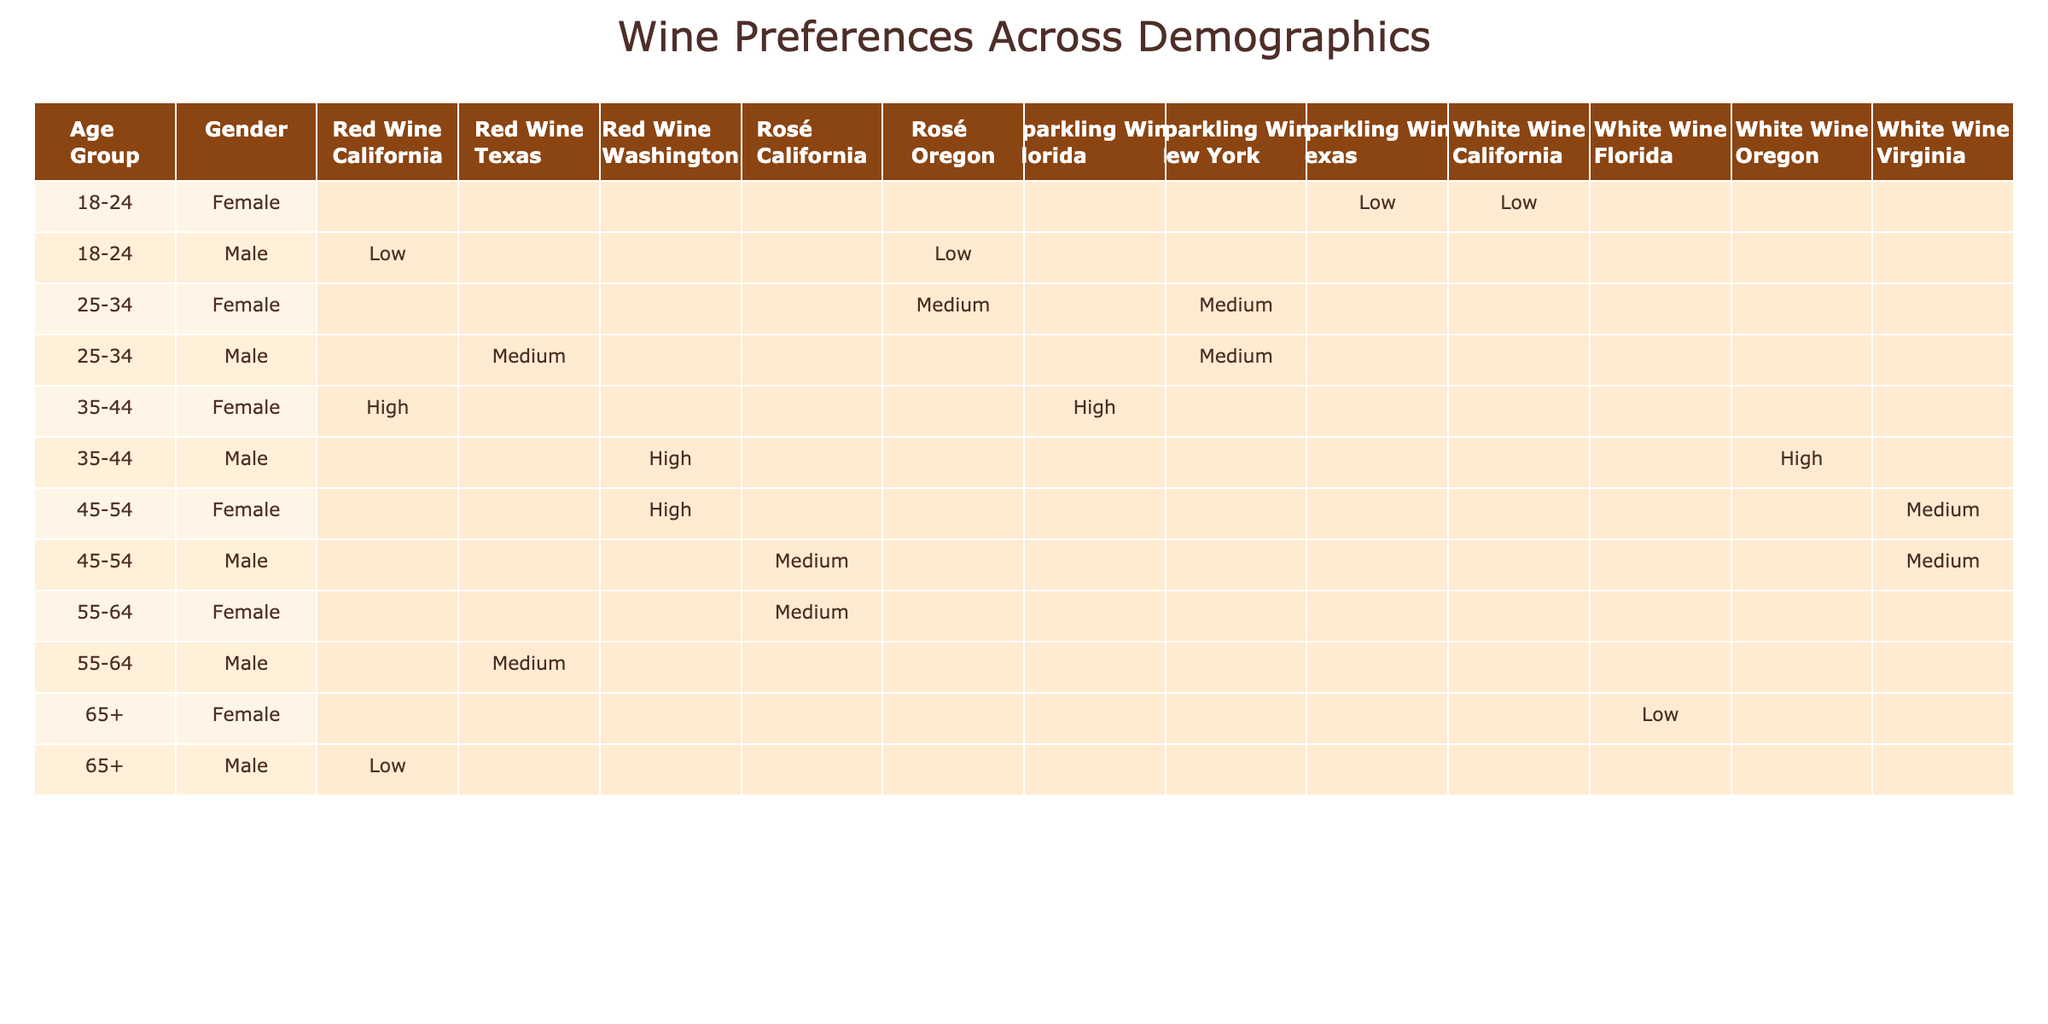What wine preference is most common among females in the 35-44 age group? In the 35-44 age group, the table indicates that females prefer "Red Wine" since it's the only wine type listed for this demographic in the table.
Answer: Red Wine What regions are associated with male consumers who prefer White Wine? The table shows males preferring White Wine in Oregon and Virginia. Therefore, the regions associated with this preference are Oregon and Virginia.
Answer: Oregon, Virginia Which age group has the highest variety of wine preferences listed in the table? By reviewing the table, the 25-34 age group shows four different wine preferences (Sparkling Wine, Red Wine, Rosé, and the specific regions). Hence, this age group has the highest variety of preferences.
Answer: 25-34 Are there any males in the 45-54 age group who prefer Rosé? Looking at the 45-54 age group in the table, there is one male who prefers Rosé, as indicated by the entry. Therefore, the statement is true.
Answer: Yes Among all demographics in California, which type of wine is preferred? By examining the California entries, White Wine is preferred by females aged 18-24 and males aged 35-44, while Red Wine is preferred by a male aged 65+. Therefore, White Wine is the most common preference in California.
Answer: White Wine How many wine types are preferred by females in the 55-64 age group? The table lists only one wine type (Rosé) for females in this age group. Therefore, the total count of preferred wine types for this group is one.
Answer: 1 What is the income level for males aged 18-24 who prefer Red Wine? The table shows that the income level for males aged 18-24 preferring Red Wine is categorized as Low. Hence, the answer is the specified income level.
Answer: Low Identify the total number of different wine preferences for females across all age groups listed in the table. By checking the entries for females, the preferences include White Wine, Sparkling Wine, Red Wine, and Rosé. Counting these gives us a total of four distinct preferences.
Answer: 4 Is there a male in the 65+ age group that prefers Sparkling Wine? The table contains no entry for males in the 65+ age group preferring Sparkling Wine, indicating that the answer to the query is false.
Answer: No For the 45-54 age group, which region has the least preference for any wine type and what is that preference? The table indicates that Virginia has two noted wine preferences (White Wine, and Rosé), while Washington shows only one (Red Wine), making Washington the least preferred region with just one wine.
Answer: Washington, Red Wine 